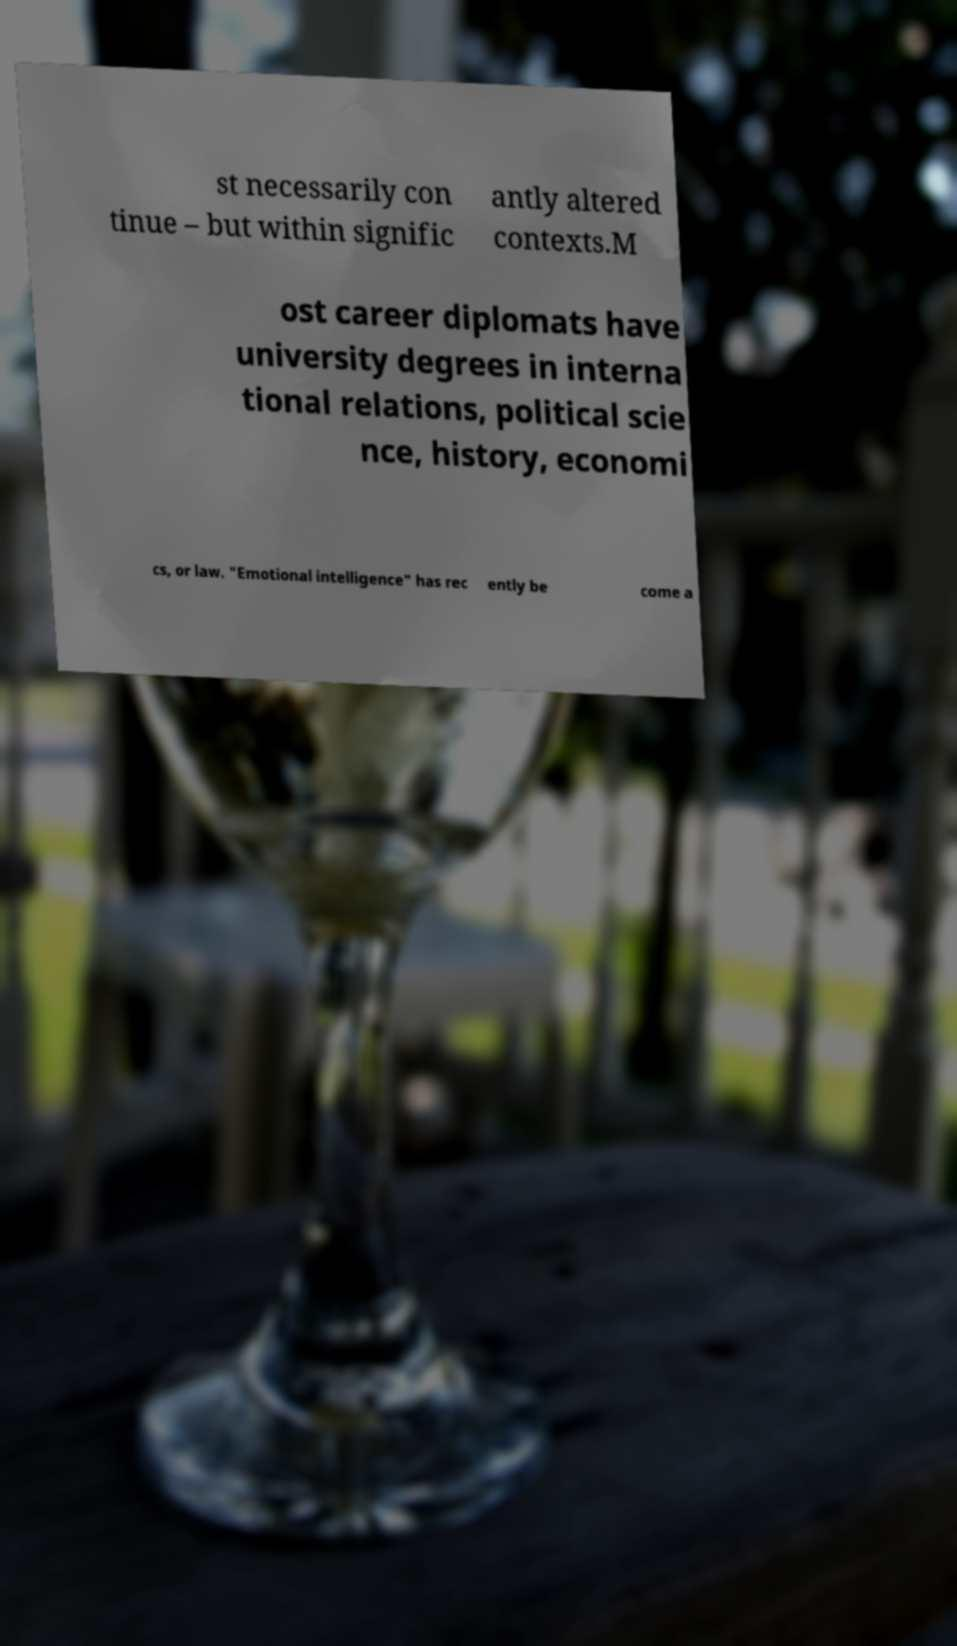Can you read and provide the text displayed in the image?This photo seems to have some interesting text. Can you extract and type it out for me? st necessarily con tinue – but within signific antly altered contexts.M ost career diplomats have university degrees in interna tional relations, political scie nce, history, economi cs, or law. "Emotional intelligence" has rec ently be come a 